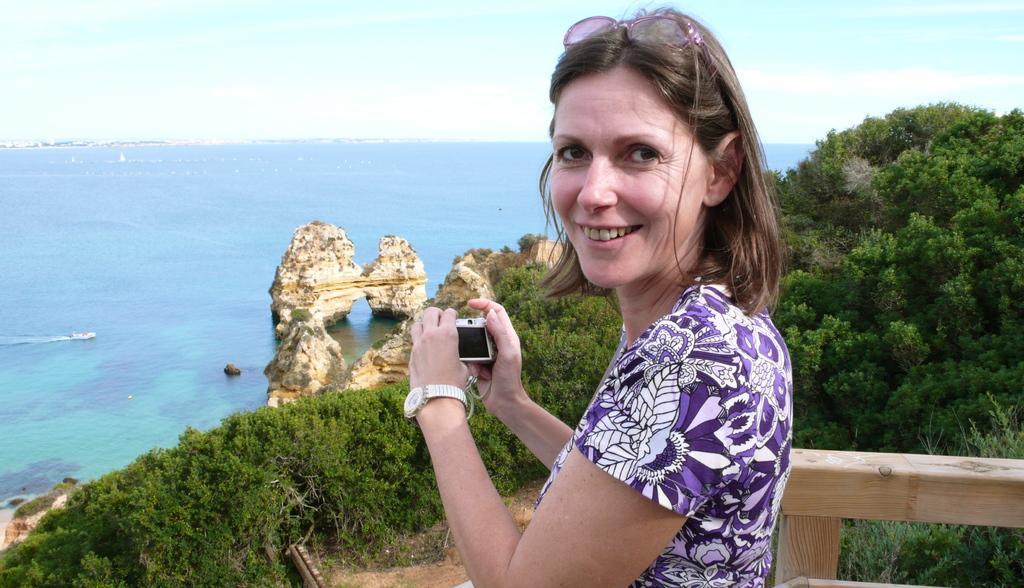Could you give a brief overview of what you see in this image? A woman is standing and smiling, she wore purple color dress, on the left side it is the beach. On the right side there are trees. 